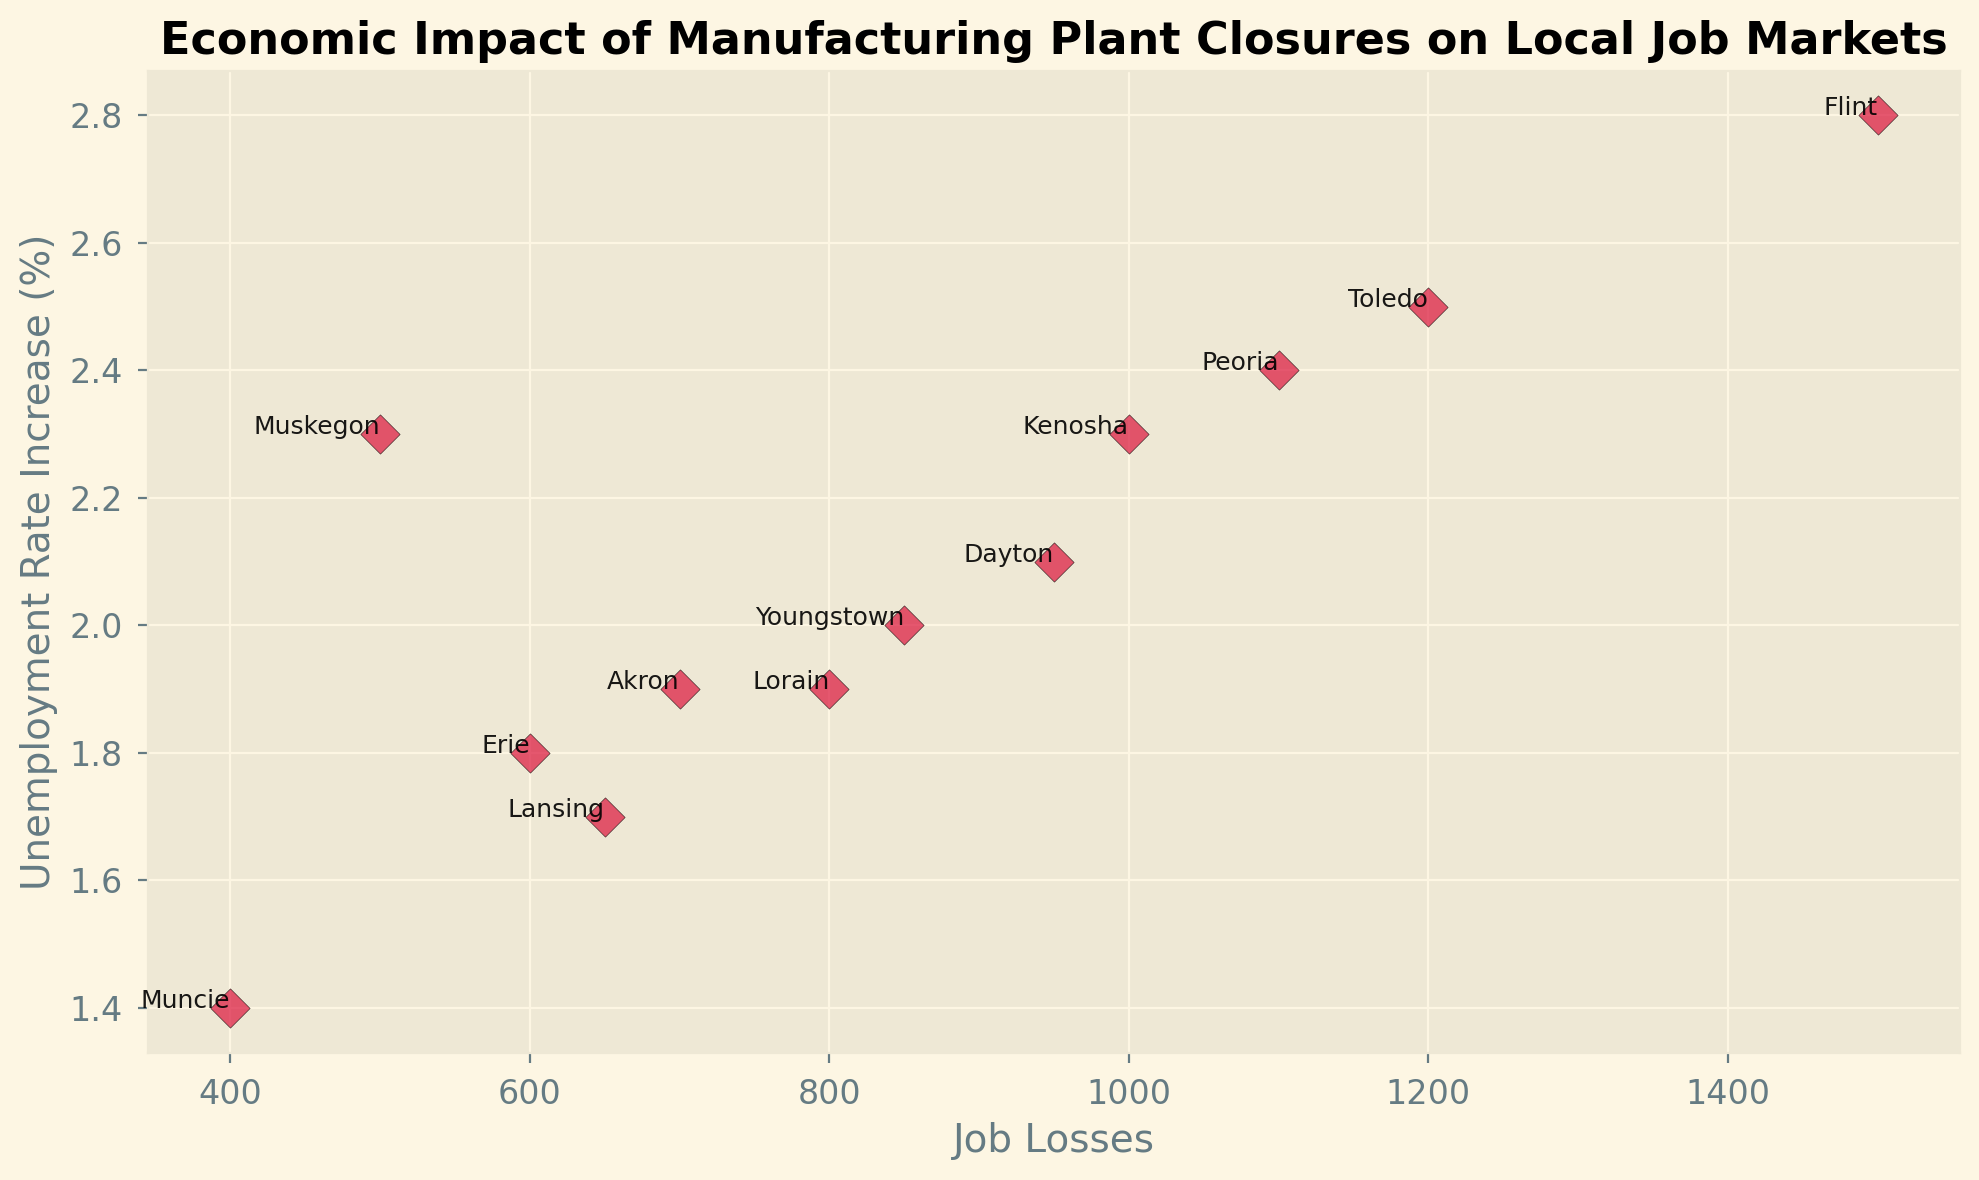What is the total number of job losses in Muskegon and Flint? To find the total job losses, sum the job losses in Muskegon and Flint. Muskegon has 500 job losses and Flint has 1500 job losses. Thus, 500 + 1500 = 2000
Answer: 2000 Which location had the highest increase in unemployment rate? From the scatter plot, locate the point with the highest value on the y-axis. Flint has the highest unemployment rate increase of 2.8%
Answer: Flint Is the job loss in Toledo greater than the job loss in Kenosha? Check the values for Toledo and Kenosha. Toledo has 1200 job losses while Kenosha has 1000 job losses. Since 1200 > 1000, Toledo has more job losses
Answer: Yes Which year experienced the smallest job loss in the given dataset? Locate the data point with the smallest job loss on the x-axis. From the dataset, Muncie in 2019 experienced the smallest job loss with 400
Answer: 2019 (Muncie) What is the average unemployment rate increase across all locations? Sum all unemployment rate increases and divide by the number of locations. \( (2.3 + 1.9 + 2.8 + 2.0 + 2.1 + 1.8 + 1.7 + 2.5 + 1.4 + 2.4 + 1.9 + 2.3) / 12 = 24.1 / 12 \approx 2.01 \)
Answer: 2.01 Does Youngstown have a higher unemployment rate increase than Dayton? Compare the unemployment rate increases for Youngstown and Dayton. Youngstown's rate increase is 2.0% and Dayton's is 2.1%. Since 2.0 < 2.1, Youngstown's rate increase is lower
Answer: No Which location has more job losses, Akron or Erie? Check the figures for Akron and Erie. Akron has 700 job losses while Erie has 600 job losses. Since 700 > 600, Akron has more job losses
Answer: Akron Is there any location with an unemployment rate increase equal to 2.3%? Identify the data points with a 2.3% rate increase. Muskegon in 2005 and Kenosha in 2022 both have a 2.3% increase
Answer: Yes What is the difference in job losses between Dayton and Lorain? Find the values for both locations and subtract. Dayton has 950 job losses and Lorain has 800 job losses. \( 950 - 800 = 150 \)
Answer: 150 Which location experienced a job loss of 1200 and an unemployment rate increase of 2.5%? Look for the data point corresponding to 1200 job losses and 2.5% increase. The location is Toledo in 2018
Answer: Toledo 